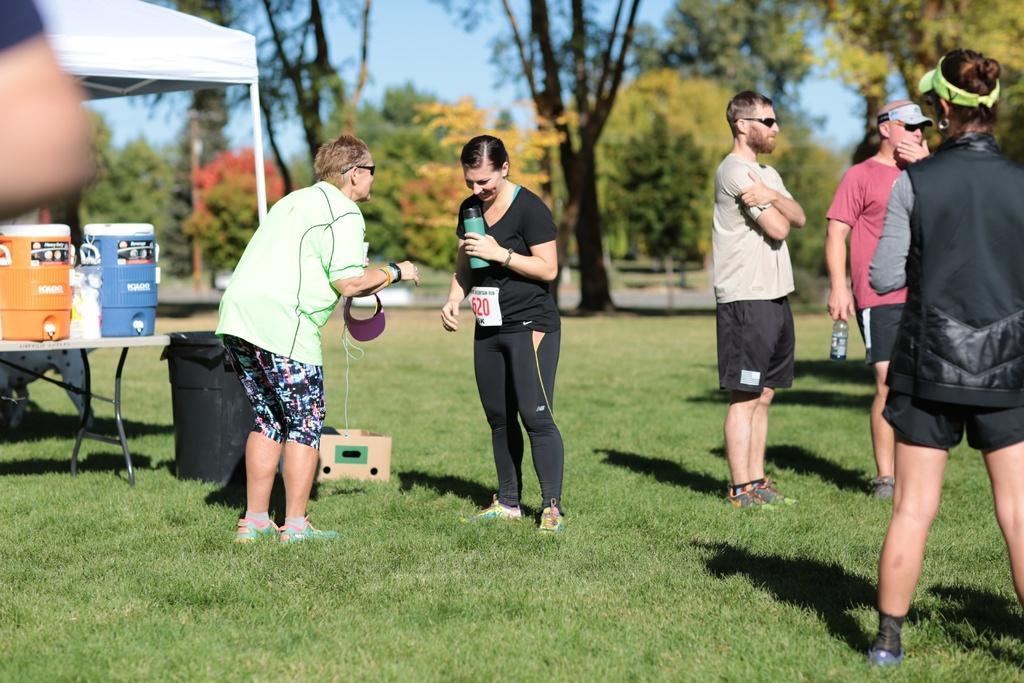How would you summarize this image in a sentence or two? In this image I can see group of people standing on the grass ground, beside them there is a tent and trees at the back. 